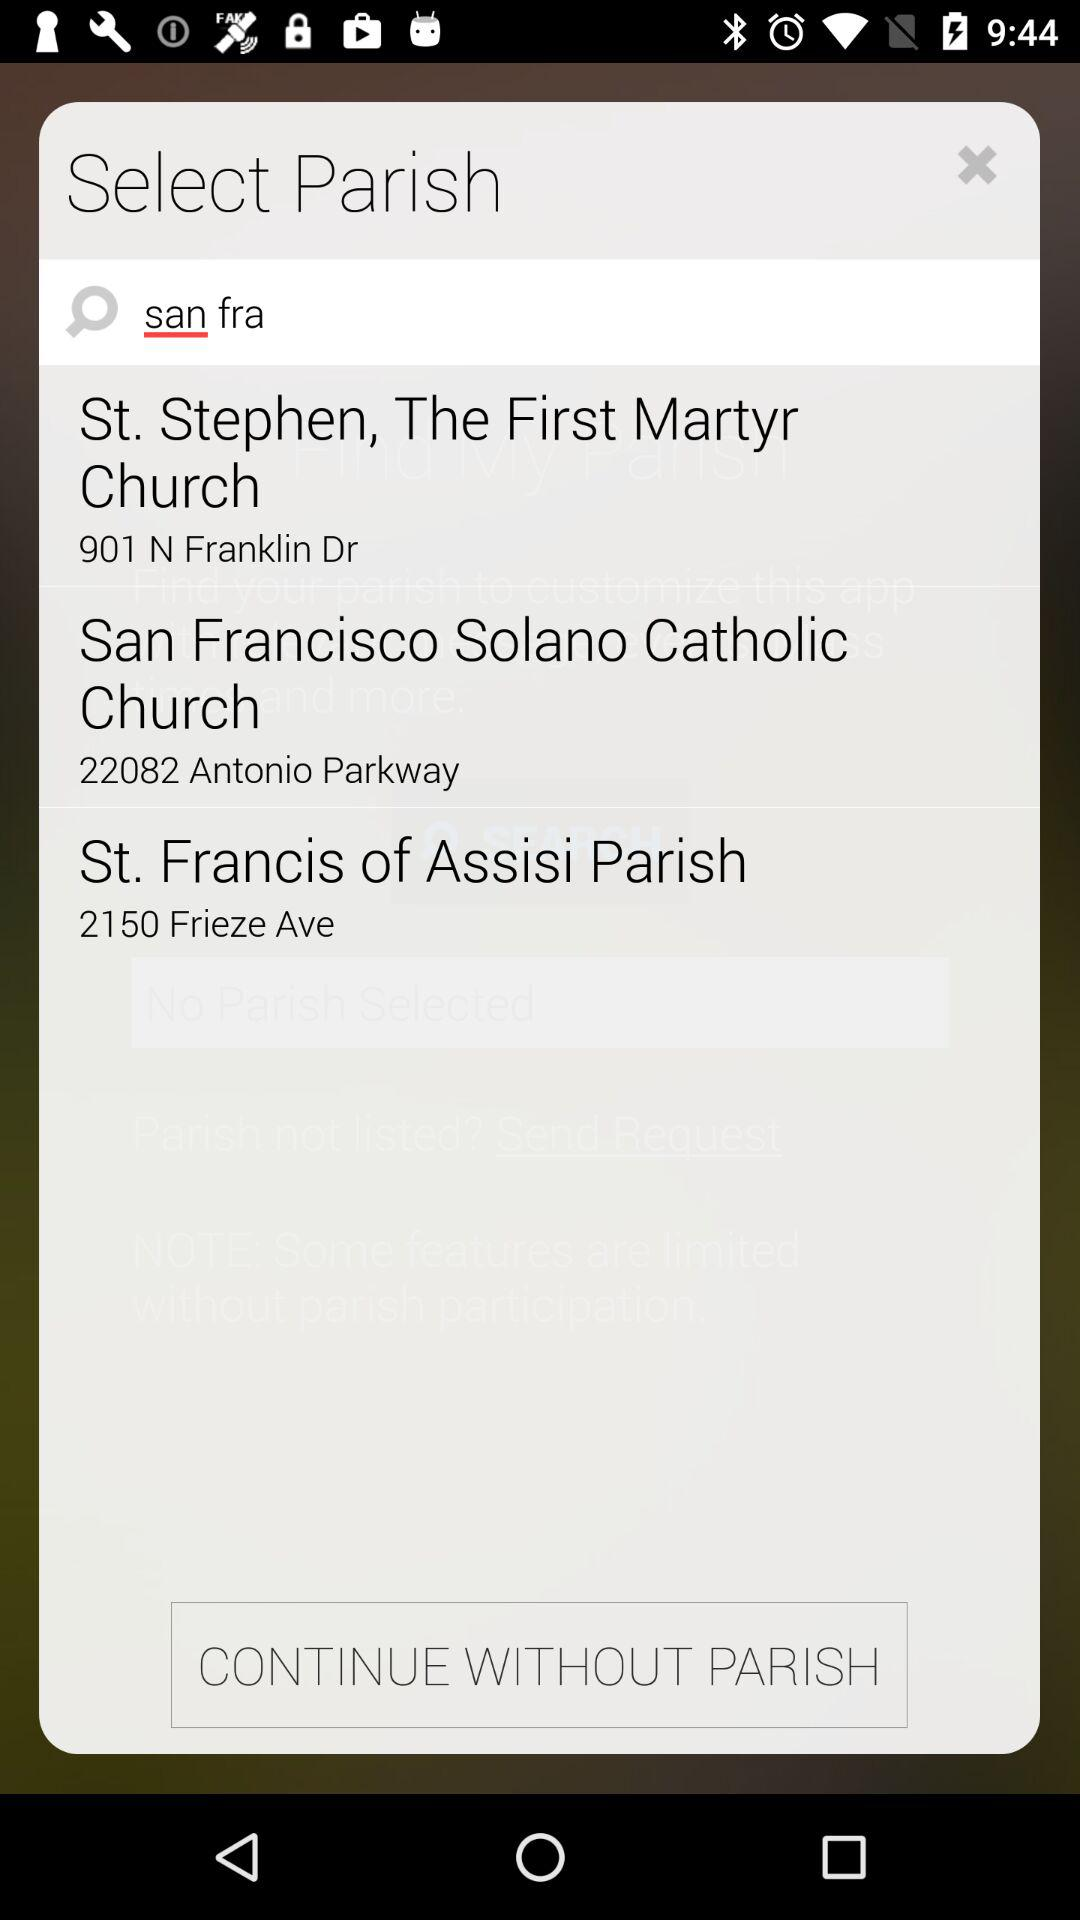What is the address of St. Stephen, The First Martyr Church? The address is "901 N Franklin Dr". 